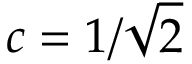Convert formula to latex. <formula><loc_0><loc_0><loc_500><loc_500>c = 1 / \sqrt { 2 }</formula> 